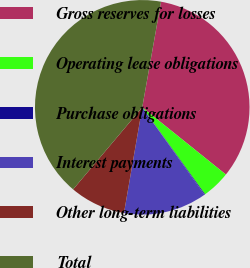Convert chart. <chart><loc_0><loc_0><loc_500><loc_500><pie_chart><fcel>Gross reserves for losses<fcel>Operating lease obligations<fcel>Purchase obligations<fcel>Interest payments<fcel>Other long-term liabilities<fcel>Total<nl><fcel>32.97%<fcel>4.27%<fcel>0.11%<fcel>12.57%<fcel>8.42%<fcel>41.65%<nl></chart> 